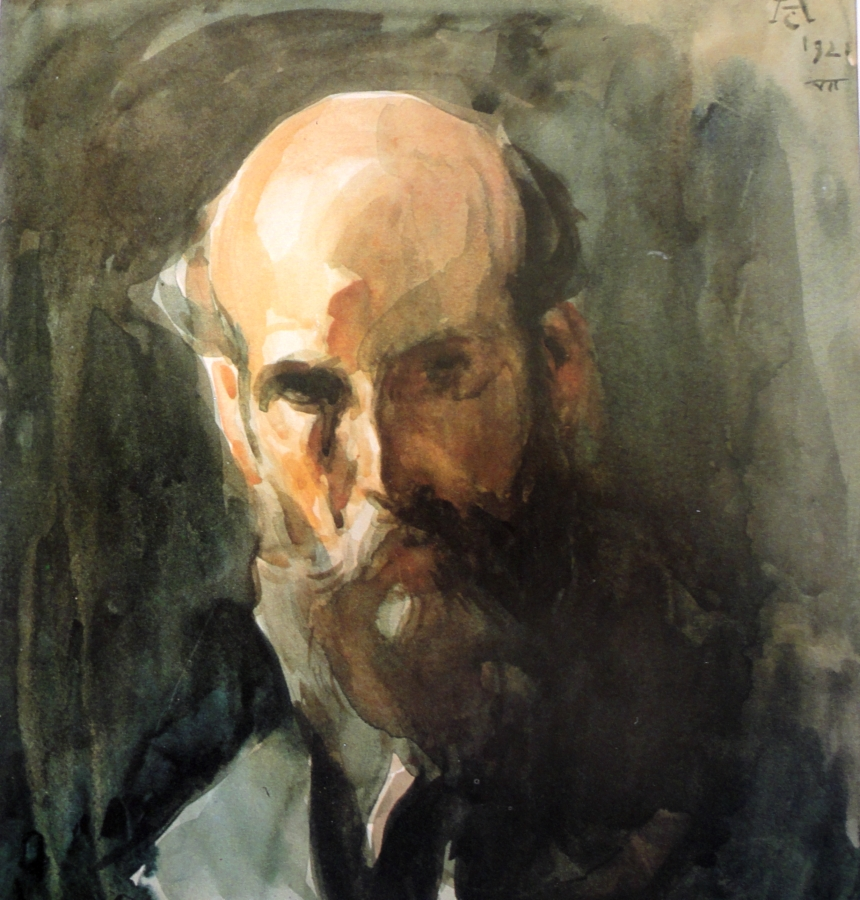Imagine a story behind this portrait. In a small, dimly lit artist’s studio, a man by the name of Elias sits for a portrait. He is a philosopher, having spent many years pondering the mysteries of existence and the human condition. His face, worn from years of contemplation, bears a stoic expression. The artist, intrigued by Elias's profound depth, tries to capture not just his appearance, but the very essence of his being. Each brushstroke aims to convey the weight of Elias’s thoughts and experiences, crafting a portrait that speaks of wisdom and solitude. 